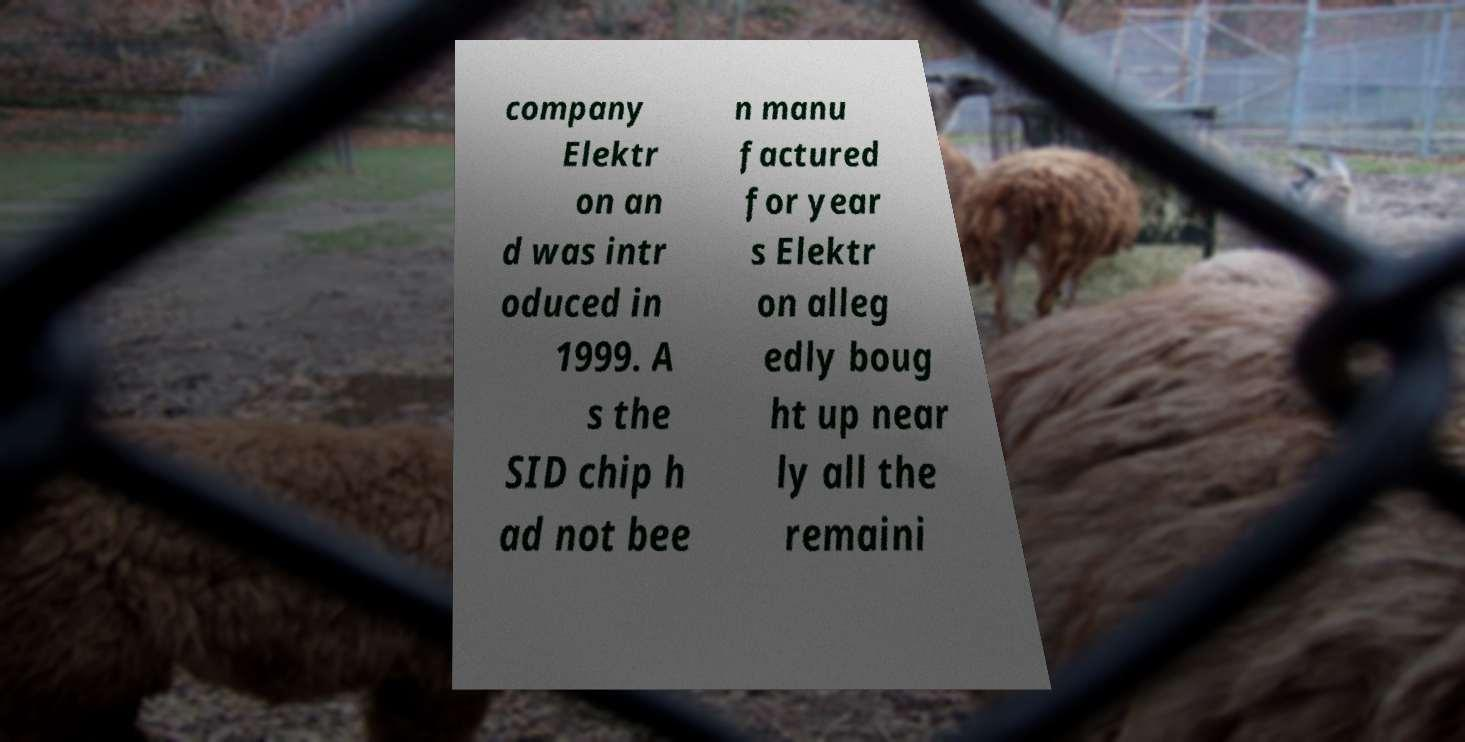I need the written content from this picture converted into text. Can you do that? company Elektr on an d was intr oduced in 1999. A s the SID chip h ad not bee n manu factured for year s Elektr on alleg edly boug ht up near ly all the remaini 